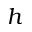Convert formula to latex. <formula><loc_0><loc_0><loc_500><loc_500>h</formula> 